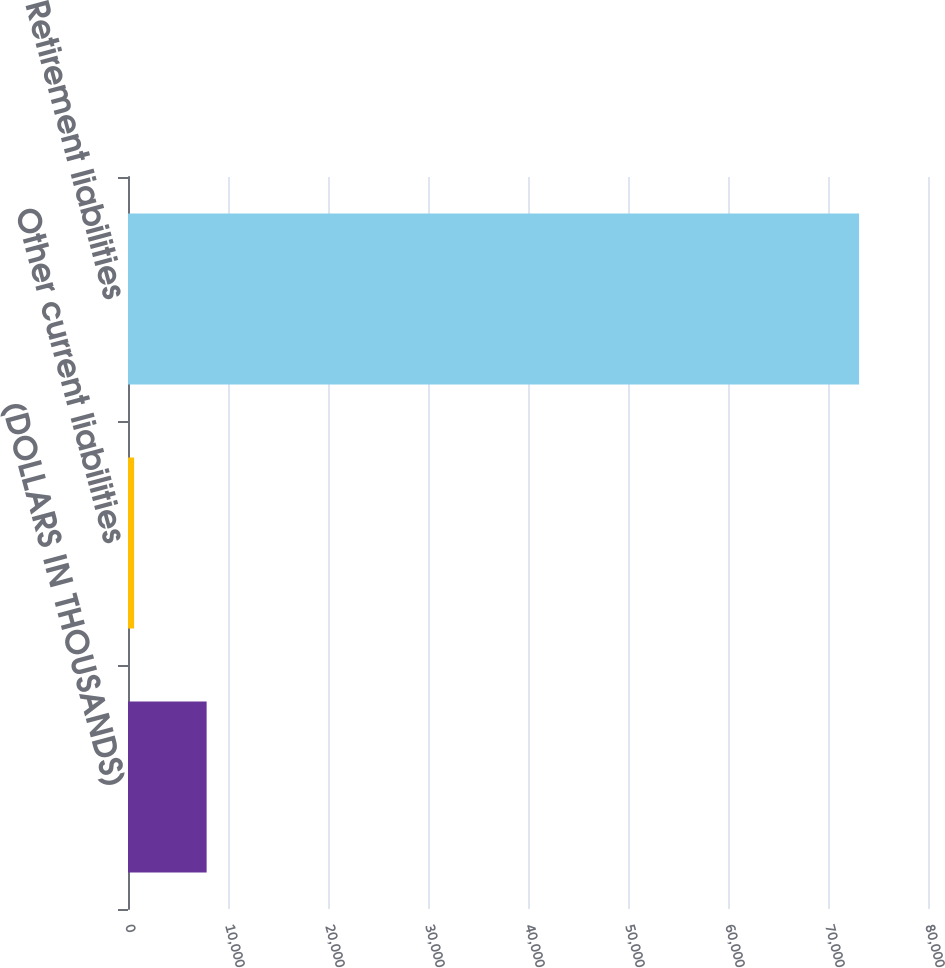Convert chart to OTSL. <chart><loc_0><loc_0><loc_500><loc_500><bar_chart><fcel>(DOLLARS IN THOUSANDS)<fcel>Other current liabilities<fcel>Retirement liabilities<nl><fcel>7862.6<fcel>613<fcel>73109<nl></chart> 